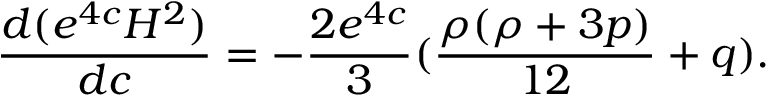Convert formula to latex. <formula><loc_0><loc_0><loc_500><loc_500>\frac { d ( e ^ { 4 c } H ^ { 2 } ) } { d c } = - \frac { 2 e ^ { 4 c } } { 3 } ( \frac { \rho ( \rho + 3 p ) } { 1 2 } + q ) .</formula> 